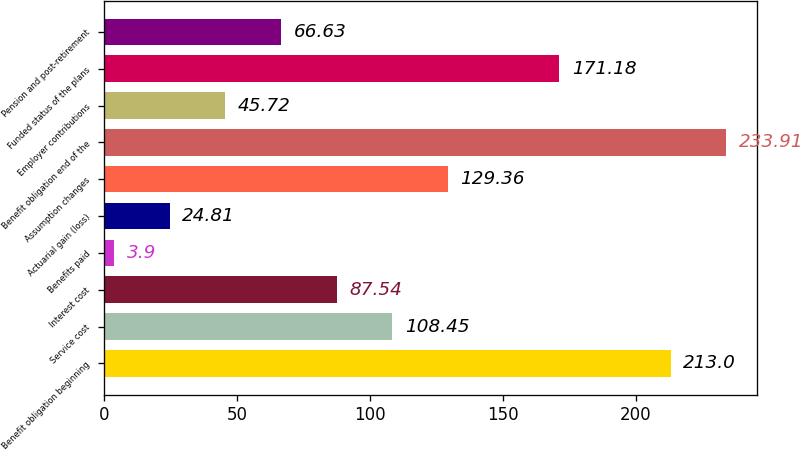<chart> <loc_0><loc_0><loc_500><loc_500><bar_chart><fcel>Benefit obligation beginning<fcel>Service cost<fcel>Interest cost<fcel>Benefits paid<fcel>Actuarial gain (loss)<fcel>Assumption changes<fcel>Benefit obligation end of the<fcel>Employer contributions<fcel>Funded status of the plans<fcel>Pension and post-retirement<nl><fcel>213<fcel>108.45<fcel>87.54<fcel>3.9<fcel>24.81<fcel>129.36<fcel>233.91<fcel>45.72<fcel>171.18<fcel>66.63<nl></chart> 